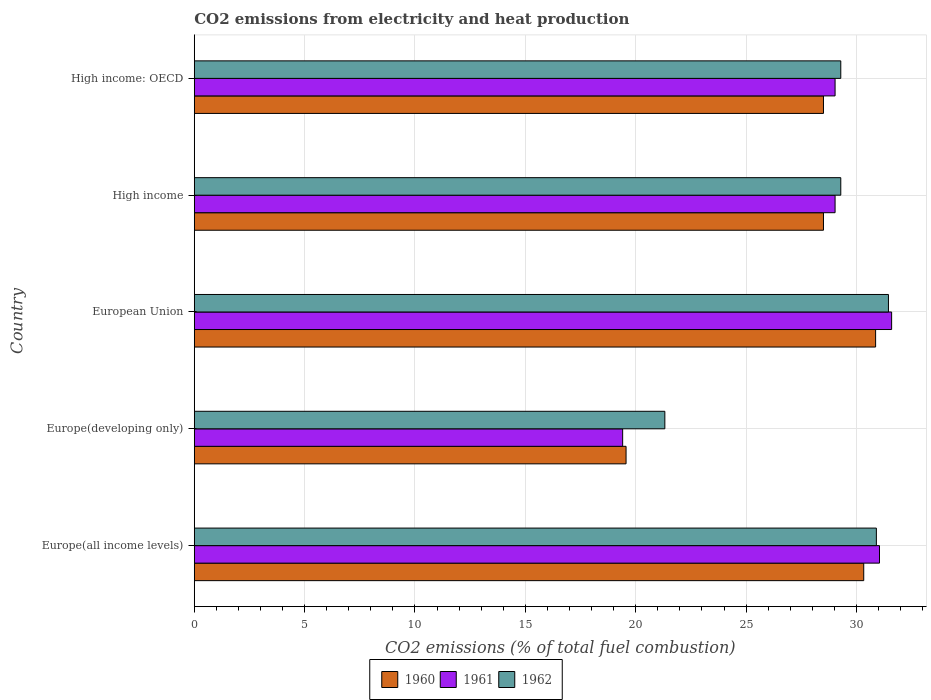How many different coloured bars are there?
Give a very brief answer. 3. Are the number of bars on each tick of the Y-axis equal?
Your response must be concise. Yes. How many bars are there on the 4th tick from the top?
Your response must be concise. 3. What is the label of the 1st group of bars from the top?
Provide a short and direct response. High income: OECD. What is the amount of CO2 emitted in 1962 in Europe(developing only)?
Keep it short and to the point. 21.32. Across all countries, what is the maximum amount of CO2 emitted in 1962?
Make the answer very short. 31.45. Across all countries, what is the minimum amount of CO2 emitted in 1961?
Your response must be concise. 19.41. In which country was the amount of CO2 emitted in 1960 maximum?
Offer a terse response. European Union. In which country was the amount of CO2 emitted in 1960 minimum?
Your answer should be very brief. Europe(developing only). What is the total amount of CO2 emitted in 1961 in the graph?
Make the answer very short. 140.11. What is the difference between the amount of CO2 emitted in 1961 in Europe(all income levels) and that in Europe(developing only)?
Provide a succinct answer. 11.64. What is the difference between the amount of CO2 emitted in 1960 in High income: OECD and the amount of CO2 emitted in 1962 in Europe(all income levels)?
Your response must be concise. -2.4. What is the average amount of CO2 emitted in 1960 per country?
Offer a terse response. 27.55. What is the difference between the amount of CO2 emitted in 1960 and amount of CO2 emitted in 1962 in High income: OECD?
Your answer should be very brief. -0.78. What is the ratio of the amount of CO2 emitted in 1960 in Europe(all income levels) to that in High income?
Give a very brief answer. 1.06. Is the amount of CO2 emitted in 1961 in Europe(all income levels) less than that in High income?
Your answer should be compact. No. Is the difference between the amount of CO2 emitted in 1960 in Europe(all income levels) and European Union greater than the difference between the amount of CO2 emitted in 1962 in Europe(all income levels) and European Union?
Your answer should be very brief. Yes. What is the difference between the highest and the second highest amount of CO2 emitted in 1961?
Provide a short and direct response. 0.55. What is the difference between the highest and the lowest amount of CO2 emitted in 1960?
Your answer should be very brief. 11.31. In how many countries, is the amount of CO2 emitted in 1962 greater than the average amount of CO2 emitted in 1962 taken over all countries?
Your answer should be compact. 4. What does the 1st bar from the bottom in High income represents?
Make the answer very short. 1960. How many countries are there in the graph?
Keep it short and to the point. 5. What is the difference between two consecutive major ticks on the X-axis?
Offer a very short reply. 5. Are the values on the major ticks of X-axis written in scientific E-notation?
Ensure brevity in your answer.  No. Does the graph contain any zero values?
Keep it short and to the point. No. Does the graph contain grids?
Provide a succinct answer. Yes. Where does the legend appear in the graph?
Offer a terse response. Bottom center. How are the legend labels stacked?
Ensure brevity in your answer.  Horizontal. What is the title of the graph?
Offer a very short reply. CO2 emissions from electricity and heat production. Does "1989" appear as one of the legend labels in the graph?
Your answer should be compact. No. What is the label or title of the X-axis?
Provide a short and direct response. CO2 emissions (% of total fuel combustion). What is the label or title of the Y-axis?
Make the answer very short. Country. What is the CO2 emissions (% of total fuel combustion) in 1960 in Europe(all income levels)?
Keep it short and to the point. 30.33. What is the CO2 emissions (% of total fuel combustion) in 1961 in Europe(all income levels)?
Give a very brief answer. 31.04. What is the CO2 emissions (% of total fuel combustion) in 1962 in Europe(all income levels)?
Offer a very short reply. 30.9. What is the CO2 emissions (% of total fuel combustion) in 1960 in Europe(developing only)?
Ensure brevity in your answer.  19.56. What is the CO2 emissions (% of total fuel combustion) of 1961 in Europe(developing only)?
Provide a short and direct response. 19.41. What is the CO2 emissions (% of total fuel combustion) of 1962 in Europe(developing only)?
Provide a succinct answer. 21.32. What is the CO2 emissions (% of total fuel combustion) in 1960 in European Union?
Provide a short and direct response. 30.87. What is the CO2 emissions (% of total fuel combustion) in 1961 in European Union?
Your answer should be very brief. 31.59. What is the CO2 emissions (% of total fuel combustion) of 1962 in European Union?
Your answer should be very brief. 31.45. What is the CO2 emissions (% of total fuel combustion) of 1960 in High income?
Offer a terse response. 28.51. What is the CO2 emissions (% of total fuel combustion) in 1961 in High income?
Your answer should be compact. 29.03. What is the CO2 emissions (% of total fuel combustion) of 1962 in High income?
Offer a very short reply. 29.29. What is the CO2 emissions (% of total fuel combustion) in 1960 in High income: OECD?
Provide a succinct answer. 28.51. What is the CO2 emissions (% of total fuel combustion) of 1961 in High income: OECD?
Offer a terse response. 29.03. What is the CO2 emissions (% of total fuel combustion) in 1962 in High income: OECD?
Make the answer very short. 29.29. Across all countries, what is the maximum CO2 emissions (% of total fuel combustion) of 1960?
Ensure brevity in your answer.  30.87. Across all countries, what is the maximum CO2 emissions (% of total fuel combustion) of 1961?
Your answer should be very brief. 31.59. Across all countries, what is the maximum CO2 emissions (% of total fuel combustion) of 1962?
Provide a succinct answer. 31.45. Across all countries, what is the minimum CO2 emissions (% of total fuel combustion) in 1960?
Provide a short and direct response. 19.56. Across all countries, what is the minimum CO2 emissions (% of total fuel combustion) in 1961?
Your answer should be very brief. 19.41. Across all countries, what is the minimum CO2 emissions (% of total fuel combustion) of 1962?
Offer a terse response. 21.32. What is the total CO2 emissions (% of total fuel combustion) of 1960 in the graph?
Keep it short and to the point. 137.77. What is the total CO2 emissions (% of total fuel combustion) in 1961 in the graph?
Ensure brevity in your answer.  140.11. What is the total CO2 emissions (% of total fuel combustion) in 1962 in the graph?
Make the answer very short. 142.25. What is the difference between the CO2 emissions (% of total fuel combustion) of 1960 in Europe(all income levels) and that in Europe(developing only)?
Offer a very short reply. 10.77. What is the difference between the CO2 emissions (% of total fuel combustion) of 1961 in Europe(all income levels) and that in Europe(developing only)?
Ensure brevity in your answer.  11.64. What is the difference between the CO2 emissions (% of total fuel combustion) of 1962 in Europe(all income levels) and that in Europe(developing only)?
Offer a terse response. 9.58. What is the difference between the CO2 emissions (% of total fuel combustion) of 1960 in Europe(all income levels) and that in European Union?
Provide a succinct answer. -0.54. What is the difference between the CO2 emissions (% of total fuel combustion) in 1961 in Europe(all income levels) and that in European Union?
Keep it short and to the point. -0.55. What is the difference between the CO2 emissions (% of total fuel combustion) of 1962 in Europe(all income levels) and that in European Union?
Ensure brevity in your answer.  -0.55. What is the difference between the CO2 emissions (% of total fuel combustion) of 1960 in Europe(all income levels) and that in High income?
Your answer should be compact. 1.82. What is the difference between the CO2 emissions (% of total fuel combustion) in 1961 in Europe(all income levels) and that in High income?
Make the answer very short. 2.01. What is the difference between the CO2 emissions (% of total fuel combustion) in 1962 in Europe(all income levels) and that in High income?
Ensure brevity in your answer.  1.61. What is the difference between the CO2 emissions (% of total fuel combustion) of 1960 in Europe(all income levels) and that in High income: OECD?
Provide a short and direct response. 1.82. What is the difference between the CO2 emissions (% of total fuel combustion) in 1961 in Europe(all income levels) and that in High income: OECD?
Offer a terse response. 2.01. What is the difference between the CO2 emissions (% of total fuel combustion) in 1962 in Europe(all income levels) and that in High income: OECD?
Provide a succinct answer. 1.61. What is the difference between the CO2 emissions (% of total fuel combustion) in 1960 in Europe(developing only) and that in European Union?
Offer a terse response. -11.31. What is the difference between the CO2 emissions (% of total fuel combustion) of 1961 in Europe(developing only) and that in European Union?
Give a very brief answer. -12.19. What is the difference between the CO2 emissions (% of total fuel combustion) in 1962 in Europe(developing only) and that in European Union?
Your response must be concise. -10.13. What is the difference between the CO2 emissions (% of total fuel combustion) of 1960 in Europe(developing only) and that in High income?
Keep it short and to the point. -8.94. What is the difference between the CO2 emissions (% of total fuel combustion) in 1961 in Europe(developing only) and that in High income?
Your answer should be very brief. -9.62. What is the difference between the CO2 emissions (% of total fuel combustion) in 1962 in Europe(developing only) and that in High income?
Your answer should be compact. -7.97. What is the difference between the CO2 emissions (% of total fuel combustion) of 1960 in Europe(developing only) and that in High income: OECD?
Provide a succinct answer. -8.94. What is the difference between the CO2 emissions (% of total fuel combustion) in 1961 in Europe(developing only) and that in High income: OECD?
Offer a very short reply. -9.62. What is the difference between the CO2 emissions (% of total fuel combustion) in 1962 in Europe(developing only) and that in High income: OECD?
Ensure brevity in your answer.  -7.97. What is the difference between the CO2 emissions (% of total fuel combustion) of 1960 in European Union and that in High income?
Make the answer very short. 2.36. What is the difference between the CO2 emissions (% of total fuel combustion) in 1961 in European Union and that in High income?
Your answer should be compact. 2.56. What is the difference between the CO2 emissions (% of total fuel combustion) in 1962 in European Union and that in High income?
Ensure brevity in your answer.  2.16. What is the difference between the CO2 emissions (% of total fuel combustion) in 1960 in European Union and that in High income: OECD?
Offer a terse response. 2.36. What is the difference between the CO2 emissions (% of total fuel combustion) of 1961 in European Union and that in High income: OECD?
Keep it short and to the point. 2.56. What is the difference between the CO2 emissions (% of total fuel combustion) in 1962 in European Union and that in High income: OECD?
Offer a terse response. 2.16. What is the difference between the CO2 emissions (% of total fuel combustion) of 1960 in High income and that in High income: OECD?
Provide a short and direct response. 0. What is the difference between the CO2 emissions (% of total fuel combustion) of 1962 in High income and that in High income: OECD?
Your response must be concise. 0. What is the difference between the CO2 emissions (% of total fuel combustion) of 1960 in Europe(all income levels) and the CO2 emissions (% of total fuel combustion) of 1961 in Europe(developing only)?
Offer a very short reply. 10.92. What is the difference between the CO2 emissions (% of total fuel combustion) of 1960 in Europe(all income levels) and the CO2 emissions (% of total fuel combustion) of 1962 in Europe(developing only)?
Make the answer very short. 9.01. What is the difference between the CO2 emissions (% of total fuel combustion) in 1961 in Europe(all income levels) and the CO2 emissions (% of total fuel combustion) in 1962 in Europe(developing only)?
Offer a terse response. 9.73. What is the difference between the CO2 emissions (% of total fuel combustion) in 1960 in Europe(all income levels) and the CO2 emissions (% of total fuel combustion) in 1961 in European Union?
Your answer should be very brief. -1.26. What is the difference between the CO2 emissions (% of total fuel combustion) in 1960 in Europe(all income levels) and the CO2 emissions (% of total fuel combustion) in 1962 in European Union?
Your answer should be compact. -1.12. What is the difference between the CO2 emissions (% of total fuel combustion) in 1961 in Europe(all income levels) and the CO2 emissions (% of total fuel combustion) in 1962 in European Union?
Provide a short and direct response. -0.41. What is the difference between the CO2 emissions (% of total fuel combustion) in 1960 in Europe(all income levels) and the CO2 emissions (% of total fuel combustion) in 1961 in High income?
Keep it short and to the point. 1.3. What is the difference between the CO2 emissions (% of total fuel combustion) of 1960 in Europe(all income levels) and the CO2 emissions (% of total fuel combustion) of 1962 in High income?
Provide a succinct answer. 1.04. What is the difference between the CO2 emissions (% of total fuel combustion) in 1961 in Europe(all income levels) and the CO2 emissions (% of total fuel combustion) in 1962 in High income?
Your response must be concise. 1.75. What is the difference between the CO2 emissions (% of total fuel combustion) of 1960 in Europe(all income levels) and the CO2 emissions (% of total fuel combustion) of 1961 in High income: OECD?
Ensure brevity in your answer.  1.3. What is the difference between the CO2 emissions (% of total fuel combustion) in 1960 in Europe(all income levels) and the CO2 emissions (% of total fuel combustion) in 1962 in High income: OECD?
Give a very brief answer. 1.04. What is the difference between the CO2 emissions (% of total fuel combustion) of 1961 in Europe(all income levels) and the CO2 emissions (% of total fuel combustion) of 1962 in High income: OECD?
Offer a very short reply. 1.75. What is the difference between the CO2 emissions (% of total fuel combustion) in 1960 in Europe(developing only) and the CO2 emissions (% of total fuel combustion) in 1961 in European Union?
Ensure brevity in your answer.  -12.03. What is the difference between the CO2 emissions (% of total fuel combustion) of 1960 in Europe(developing only) and the CO2 emissions (% of total fuel combustion) of 1962 in European Union?
Provide a short and direct response. -11.89. What is the difference between the CO2 emissions (% of total fuel combustion) of 1961 in Europe(developing only) and the CO2 emissions (% of total fuel combustion) of 1962 in European Union?
Offer a terse response. -12.04. What is the difference between the CO2 emissions (% of total fuel combustion) in 1960 in Europe(developing only) and the CO2 emissions (% of total fuel combustion) in 1961 in High income?
Provide a short and direct response. -9.47. What is the difference between the CO2 emissions (% of total fuel combustion) of 1960 in Europe(developing only) and the CO2 emissions (% of total fuel combustion) of 1962 in High income?
Give a very brief answer. -9.73. What is the difference between the CO2 emissions (% of total fuel combustion) in 1961 in Europe(developing only) and the CO2 emissions (% of total fuel combustion) in 1962 in High income?
Give a very brief answer. -9.88. What is the difference between the CO2 emissions (% of total fuel combustion) of 1960 in Europe(developing only) and the CO2 emissions (% of total fuel combustion) of 1961 in High income: OECD?
Your response must be concise. -9.47. What is the difference between the CO2 emissions (% of total fuel combustion) in 1960 in Europe(developing only) and the CO2 emissions (% of total fuel combustion) in 1962 in High income: OECD?
Offer a terse response. -9.73. What is the difference between the CO2 emissions (% of total fuel combustion) of 1961 in Europe(developing only) and the CO2 emissions (% of total fuel combustion) of 1962 in High income: OECD?
Provide a short and direct response. -9.88. What is the difference between the CO2 emissions (% of total fuel combustion) of 1960 in European Union and the CO2 emissions (% of total fuel combustion) of 1961 in High income?
Your response must be concise. 1.84. What is the difference between the CO2 emissions (% of total fuel combustion) of 1960 in European Union and the CO2 emissions (% of total fuel combustion) of 1962 in High income?
Your response must be concise. 1.58. What is the difference between the CO2 emissions (% of total fuel combustion) of 1961 in European Union and the CO2 emissions (% of total fuel combustion) of 1962 in High income?
Offer a terse response. 2.3. What is the difference between the CO2 emissions (% of total fuel combustion) of 1960 in European Union and the CO2 emissions (% of total fuel combustion) of 1961 in High income: OECD?
Your answer should be very brief. 1.84. What is the difference between the CO2 emissions (% of total fuel combustion) in 1960 in European Union and the CO2 emissions (% of total fuel combustion) in 1962 in High income: OECD?
Offer a terse response. 1.58. What is the difference between the CO2 emissions (% of total fuel combustion) of 1961 in European Union and the CO2 emissions (% of total fuel combustion) of 1962 in High income: OECD?
Your response must be concise. 2.3. What is the difference between the CO2 emissions (% of total fuel combustion) of 1960 in High income and the CO2 emissions (% of total fuel combustion) of 1961 in High income: OECD?
Your response must be concise. -0.53. What is the difference between the CO2 emissions (% of total fuel combustion) in 1960 in High income and the CO2 emissions (% of total fuel combustion) in 1962 in High income: OECD?
Offer a very short reply. -0.78. What is the difference between the CO2 emissions (% of total fuel combustion) in 1961 in High income and the CO2 emissions (% of total fuel combustion) in 1962 in High income: OECD?
Your answer should be very brief. -0.26. What is the average CO2 emissions (% of total fuel combustion) of 1960 per country?
Ensure brevity in your answer.  27.55. What is the average CO2 emissions (% of total fuel combustion) in 1961 per country?
Your answer should be very brief. 28.02. What is the average CO2 emissions (% of total fuel combustion) in 1962 per country?
Your answer should be compact. 28.45. What is the difference between the CO2 emissions (% of total fuel combustion) in 1960 and CO2 emissions (% of total fuel combustion) in 1961 in Europe(all income levels)?
Give a very brief answer. -0.71. What is the difference between the CO2 emissions (% of total fuel combustion) of 1960 and CO2 emissions (% of total fuel combustion) of 1962 in Europe(all income levels)?
Provide a short and direct response. -0.57. What is the difference between the CO2 emissions (% of total fuel combustion) in 1961 and CO2 emissions (% of total fuel combustion) in 1962 in Europe(all income levels)?
Keep it short and to the point. 0.14. What is the difference between the CO2 emissions (% of total fuel combustion) of 1960 and CO2 emissions (% of total fuel combustion) of 1961 in Europe(developing only)?
Keep it short and to the point. 0.15. What is the difference between the CO2 emissions (% of total fuel combustion) of 1960 and CO2 emissions (% of total fuel combustion) of 1962 in Europe(developing only)?
Ensure brevity in your answer.  -1.76. What is the difference between the CO2 emissions (% of total fuel combustion) of 1961 and CO2 emissions (% of total fuel combustion) of 1962 in Europe(developing only)?
Offer a terse response. -1.91. What is the difference between the CO2 emissions (% of total fuel combustion) in 1960 and CO2 emissions (% of total fuel combustion) in 1961 in European Union?
Offer a very short reply. -0.73. What is the difference between the CO2 emissions (% of total fuel combustion) of 1960 and CO2 emissions (% of total fuel combustion) of 1962 in European Union?
Offer a terse response. -0.58. What is the difference between the CO2 emissions (% of total fuel combustion) of 1961 and CO2 emissions (% of total fuel combustion) of 1962 in European Union?
Your answer should be very brief. 0.14. What is the difference between the CO2 emissions (% of total fuel combustion) of 1960 and CO2 emissions (% of total fuel combustion) of 1961 in High income?
Provide a short and direct response. -0.53. What is the difference between the CO2 emissions (% of total fuel combustion) of 1960 and CO2 emissions (% of total fuel combustion) of 1962 in High income?
Your answer should be very brief. -0.78. What is the difference between the CO2 emissions (% of total fuel combustion) in 1961 and CO2 emissions (% of total fuel combustion) in 1962 in High income?
Make the answer very short. -0.26. What is the difference between the CO2 emissions (% of total fuel combustion) in 1960 and CO2 emissions (% of total fuel combustion) in 1961 in High income: OECD?
Offer a very short reply. -0.53. What is the difference between the CO2 emissions (% of total fuel combustion) of 1960 and CO2 emissions (% of total fuel combustion) of 1962 in High income: OECD?
Provide a succinct answer. -0.78. What is the difference between the CO2 emissions (% of total fuel combustion) of 1961 and CO2 emissions (% of total fuel combustion) of 1962 in High income: OECD?
Offer a very short reply. -0.26. What is the ratio of the CO2 emissions (% of total fuel combustion) in 1960 in Europe(all income levels) to that in Europe(developing only)?
Offer a very short reply. 1.55. What is the ratio of the CO2 emissions (% of total fuel combustion) of 1961 in Europe(all income levels) to that in Europe(developing only)?
Keep it short and to the point. 1.6. What is the ratio of the CO2 emissions (% of total fuel combustion) in 1962 in Europe(all income levels) to that in Europe(developing only)?
Keep it short and to the point. 1.45. What is the ratio of the CO2 emissions (% of total fuel combustion) in 1960 in Europe(all income levels) to that in European Union?
Your answer should be very brief. 0.98. What is the ratio of the CO2 emissions (% of total fuel combustion) of 1961 in Europe(all income levels) to that in European Union?
Keep it short and to the point. 0.98. What is the ratio of the CO2 emissions (% of total fuel combustion) of 1962 in Europe(all income levels) to that in European Union?
Your response must be concise. 0.98. What is the ratio of the CO2 emissions (% of total fuel combustion) in 1960 in Europe(all income levels) to that in High income?
Offer a terse response. 1.06. What is the ratio of the CO2 emissions (% of total fuel combustion) of 1961 in Europe(all income levels) to that in High income?
Provide a short and direct response. 1.07. What is the ratio of the CO2 emissions (% of total fuel combustion) in 1962 in Europe(all income levels) to that in High income?
Your answer should be very brief. 1.06. What is the ratio of the CO2 emissions (% of total fuel combustion) of 1960 in Europe(all income levels) to that in High income: OECD?
Provide a succinct answer. 1.06. What is the ratio of the CO2 emissions (% of total fuel combustion) in 1961 in Europe(all income levels) to that in High income: OECD?
Your answer should be compact. 1.07. What is the ratio of the CO2 emissions (% of total fuel combustion) of 1962 in Europe(all income levels) to that in High income: OECD?
Offer a very short reply. 1.06. What is the ratio of the CO2 emissions (% of total fuel combustion) of 1960 in Europe(developing only) to that in European Union?
Offer a terse response. 0.63. What is the ratio of the CO2 emissions (% of total fuel combustion) in 1961 in Europe(developing only) to that in European Union?
Provide a short and direct response. 0.61. What is the ratio of the CO2 emissions (% of total fuel combustion) of 1962 in Europe(developing only) to that in European Union?
Your answer should be very brief. 0.68. What is the ratio of the CO2 emissions (% of total fuel combustion) in 1960 in Europe(developing only) to that in High income?
Make the answer very short. 0.69. What is the ratio of the CO2 emissions (% of total fuel combustion) in 1961 in Europe(developing only) to that in High income?
Ensure brevity in your answer.  0.67. What is the ratio of the CO2 emissions (% of total fuel combustion) in 1962 in Europe(developing only) to that in High income?
Offer a terse response. 0.73. What is the ratio of the CO2 emissions (% of total fuel combustion) in 1960 in Europe(developing only) to that in High income: OECD?
Offer a very short reply. 0.69. What is the ratio of the CO2 emissions (% of total fuel combustion) of 1961 in Europe(developing only) to that in High income: OECD?
Keep it short and to the point. 0.67. What is the ratio of the CO2 emissions (% of total fuel combustion) in 1962 in Europe(developing only) to that in High income: OECD?
Give a very brief answer. 0.73. What is the ratio of the CO2 emissions (% of total fuel combustion) in 1960 in European Union to that in High income?
Your response must be concise. 1.08. What is the ratio of the CO2 emissions (% of total fuel combustion) of 1961 in European Union to that in High income?
Make the answer very short. 1.09. What is the ratio of the CO2 emissions (% of total fuel combustion) in 1962 in European Union to that in High income?
Make the answer very short. 1.07. What is the ratio of the CO2 emissions (% of total fuel combustion) of 1960 in European Union to that in High income: OECD?
Provide a succinct answer. 1.08. What is the ratio of the CO2 emissions (% of total fuel combustion) in 1961 in European Union to that in High income: OECD?
Your answer should be compact. 1.09. What is the ratio of the CO2 emissions (% of total fuel combustion) in 1962 in European Union to that in High income: OECD?
Offer a very short reply. 1.07. What is the ratio of the CO2 emissions (% of total fuel combustion) of 1962 in High income to that in High income: OECD?
Ensure brevity in your answer.  1. What is the difference between the highest and the second highest CO2 emissions (% of total fuel combustion) in 1960?
Keep it short and to the point. 0.54. What is the difference between the highest and the second highest CO2 emissions (% of total fuel combustion) in 1961?
Provide a succinct answer. 0.55. What is the difference between the highest and the second highest CO2 emissions (% of total fuel combustion) in 1962?
Your response must be concise. 0.55. What is the difference between the highest and the lowest CO2 emissions (% of total fuel combustion) in 1960?
Offer a very short reply. 11.31. What is the difference between the highest and the lowest CO2 emissions (% of total fuel combustion) of 1961?
Give a very brief answer. 12.19. What is the difference between the highest and the lowest CO2 emissions (% of total fuel combustion) in 1962?
Your answer should be compact. 10.13. 